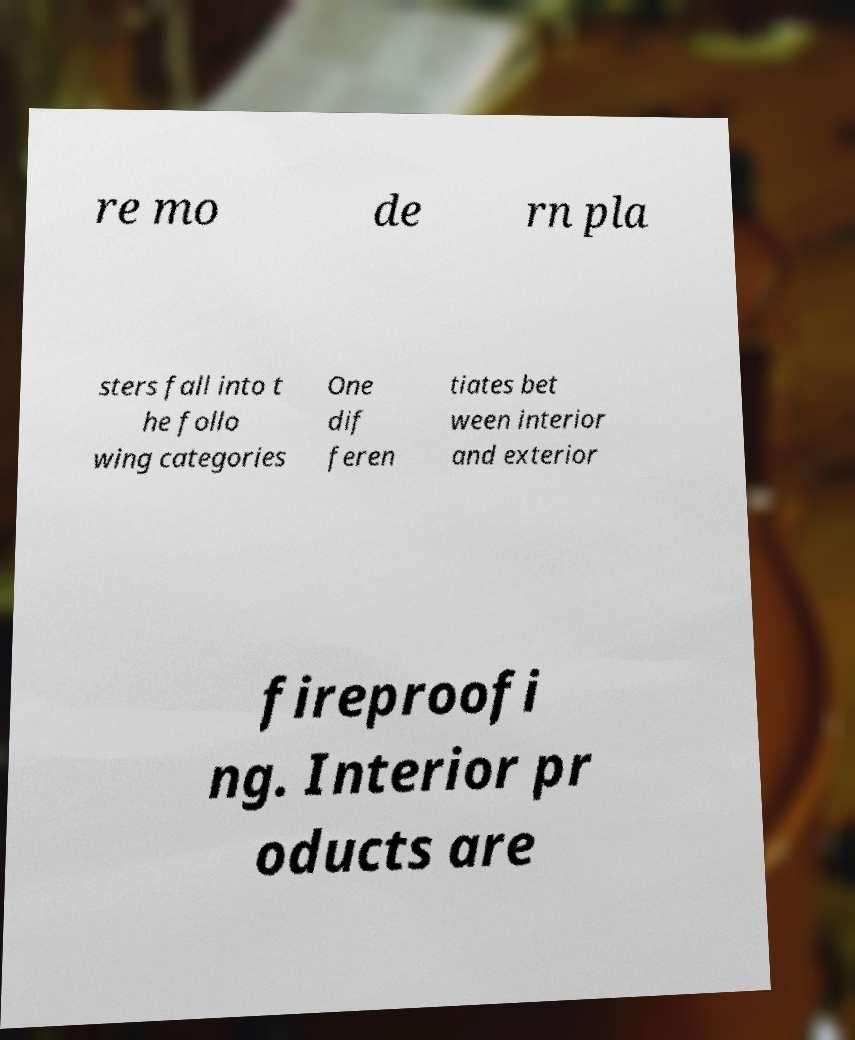Can you read and provide the text displayed in the image?This photo seems to have some interesting text. Can you extract and type it out for me? re mo de rn pla sters fall into t he follo wing categories One dif feren tiates bet ween interior and exterior fireproofi ng. Interior pr oducts are 